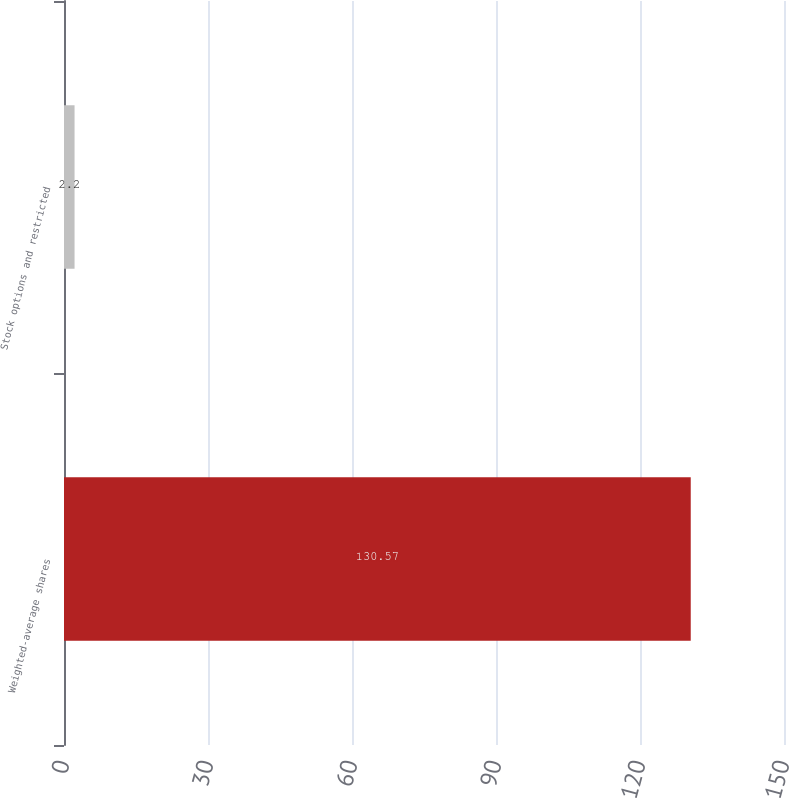<chart> <loc_0><loc_0><loc_500><loc_500><bar_chart><fcel>Weighted-average shares<fcel>Stock options and restricted<nl><fcel>130.57<fcel>2.2<nl></chart> 